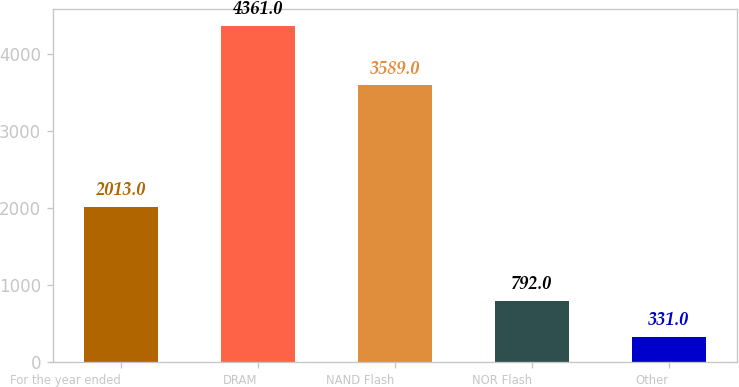Convert chart. <chart><loc_0><loc_0><loc_500><loc_500><bar_chart><fcel>For the year ended<fcel>DRAM<fcel>NAND Flash<fcel>NOR Flash<fcel>Other<nl><fcel>2013<fcel>4361<fcel>3589<fcel>792<fcel>331<nl></chart> 